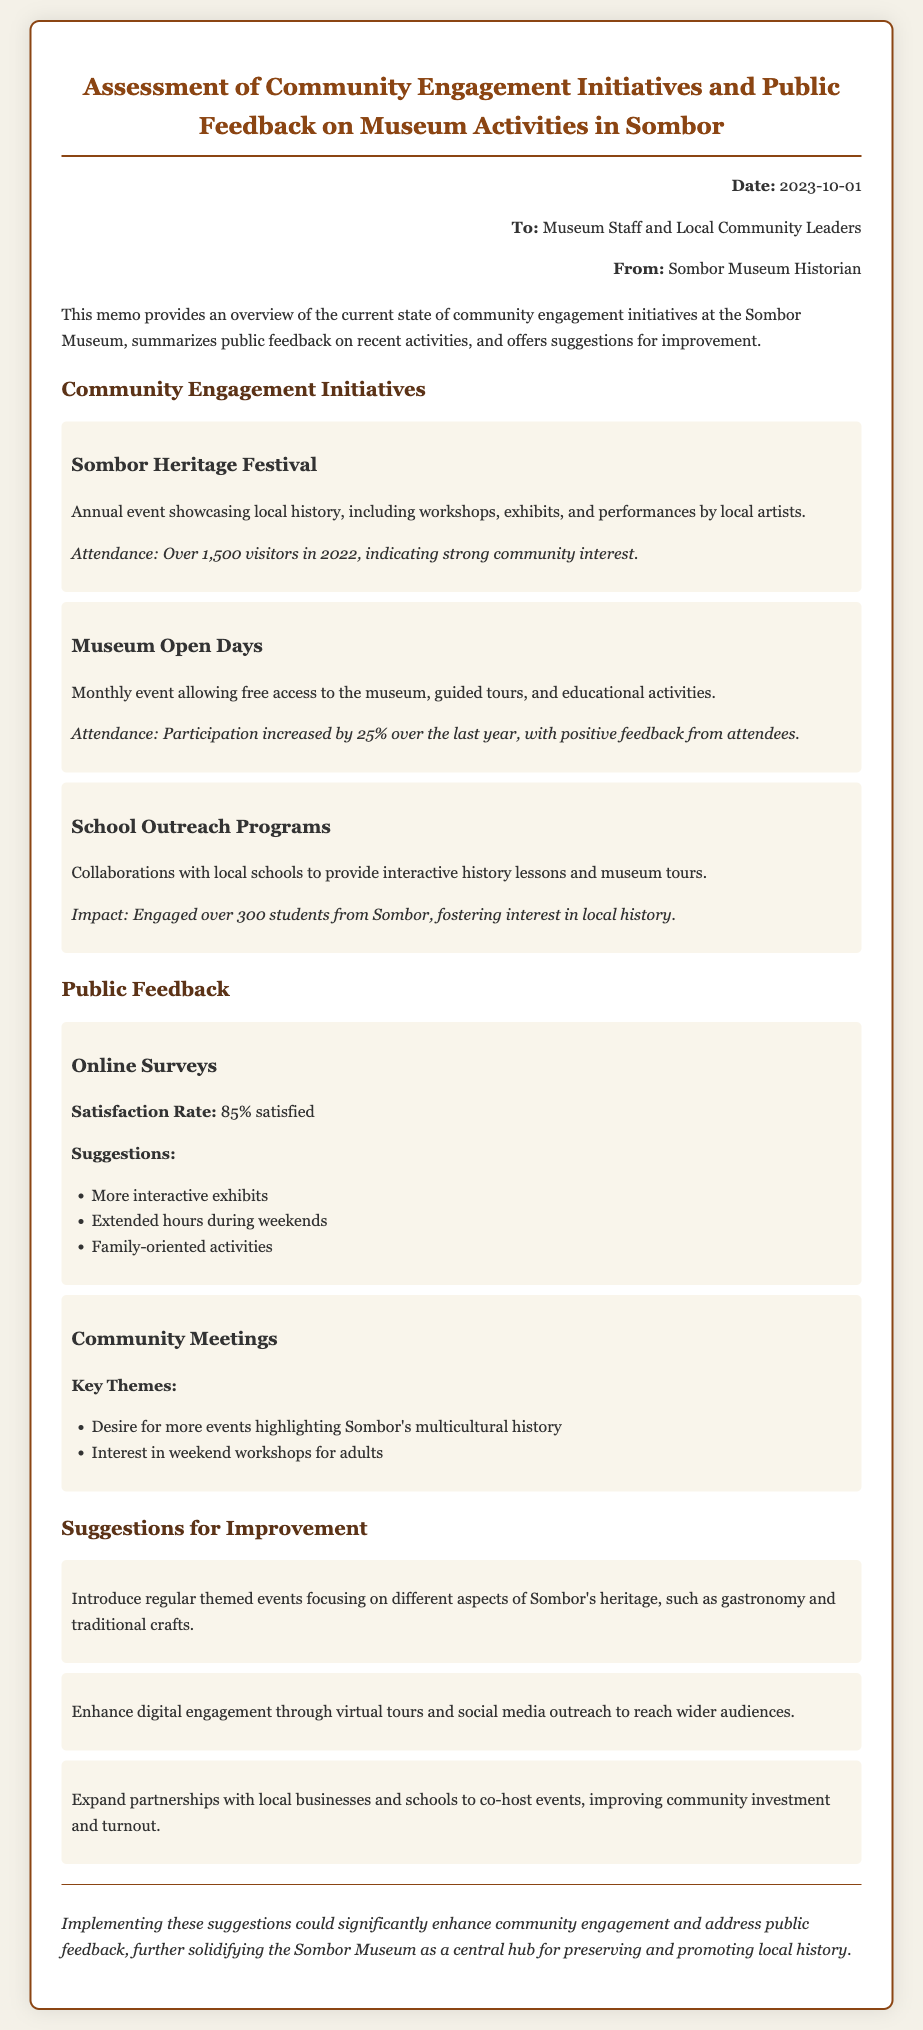What is the date of the memo? The date of the memo is provided in the header section.
Answer: 2023-10-01 Who is the memo addressed to? The memo lists the recipients in the header section.
Answer: Museum Staff and Local Community Leaders What is the attendance for the Sombor Heritage Festival in 2022? The attendance figure is mentioned under the community engagement initiatives.
Answer: Over 1,500 visitors What percentage of satisfaction was reported from the online surveys? The satisfaction rate is clearly stated in the public feedback section.
Answer: 85% satisfied What is one key theme mentioned in the community meetings? Key themes are outlined in the feedback method section regarding community meetings.
Answer: Desire for more events highlighting Sombor's multicultural history What type of programs does the School Outreach initiative include? The type of programs is specified in the description of the initiative.
Answer: Interactive history lessons and museum tours What is one suggestion for enhancing digital engagement? The suggestions for improvement section lists this information.
Answer: Virtual tours How has participation in Museum Open Days changed over the last year? The participation change is mentioned in the community engagement section.
Answer: Increased by 25% What type of event is suggested to focus on Sombor's gastronomy? The suggestion for themed events is provided in the suggestions for improvement section.
Answer: Themed events focusing on gastronomy and traditional crafts 